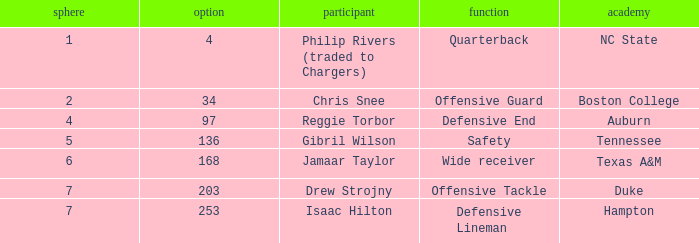Would you mind parsing the complete table? {'header': ['sphere', 'option', 'participant', 'function', 'academy'], 'rows': [['1', '4', 'Philip Rivers (traded to Chargers)', 'Quarterback', 'NC State'], ['2', '34', 'Chris Snee', 'Offensive Guard', 'Boston College'], ['4', '97', 'Reggie Torbor', 'Defensive End', 'Auburn'], ['5', '136', 'Gibril Wilson', 'Safety', 'Tennessee'], ['6', '168', 'Jamaar Taylor', 'Wide receiver', 'Texas A&M'], ['7', '203', 'Drew Strojny', 'Offensive Tackle', 'Duke'], ['7', '253', 'Isaac Hilton', 'Defensive Lineman', 'Hampton']]} Which option includes a texas a&m college? 168.0. 